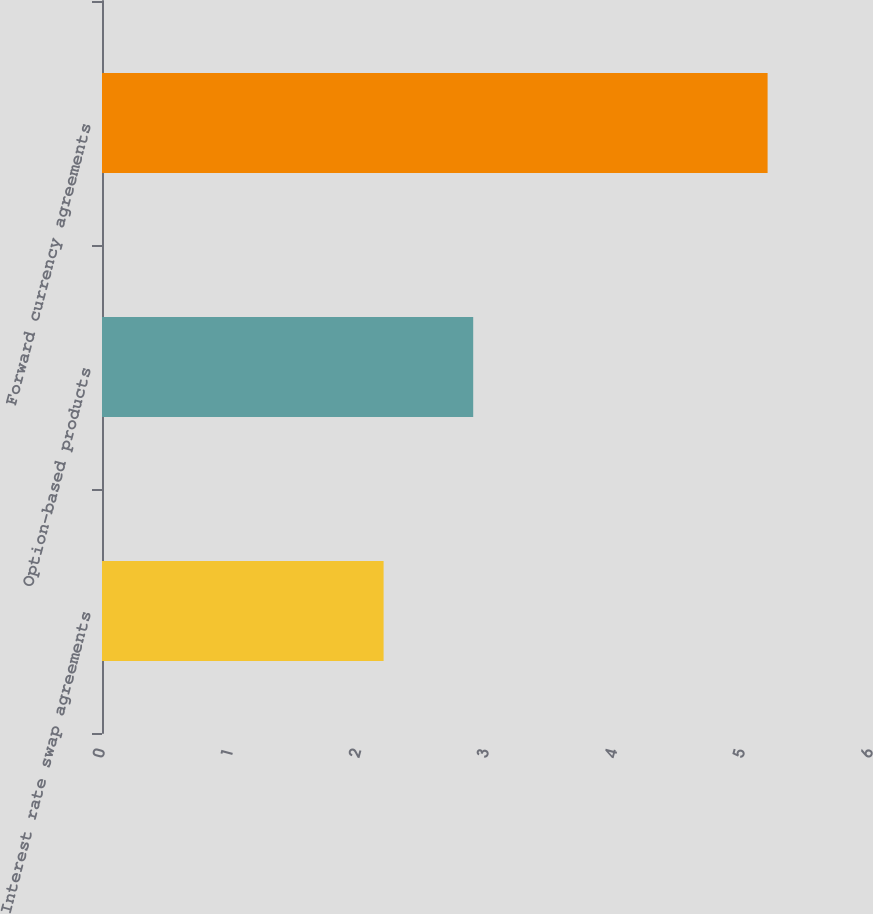<chart> <loc_0><loc_0><loc_500><loc_500><bar_chart><fcel>Interest rate swap agreements<fcel>Option-based products<fcel>Forward currency agreements<nl><fcel>2.2<fcel>2.9<fcel>5.2<nl></chart> 